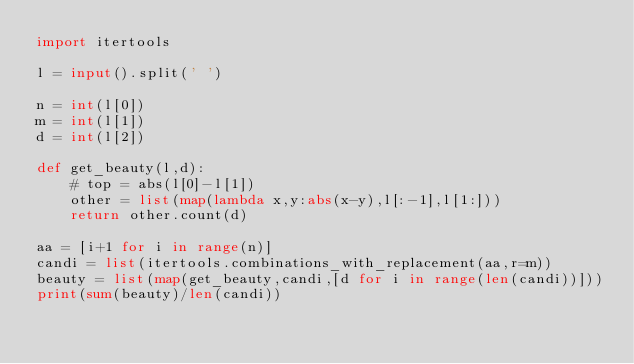<code> <loc_0><loc_0><loc_500><loc_500><_Python_>import itertools

l = input().split(' ')

n = int(l[0])
m = int(l[1])
d = int(l[2])

def get_beauty(l,d):
    # top = abs(l[0]-l[1])
    other = list(map(lambda x,y:abs(x-y),l[:-1],l[1:]))
    return other.count(d)

aa = [i+1 for i in range(n)]
candi = list(itertools.combinations_with_replacement(aa,r=m))
beauty = list(map(get_beauty,candi,[d for i in range(len(candi))]))
print(sum(beauty)/len(candi))
</code> 